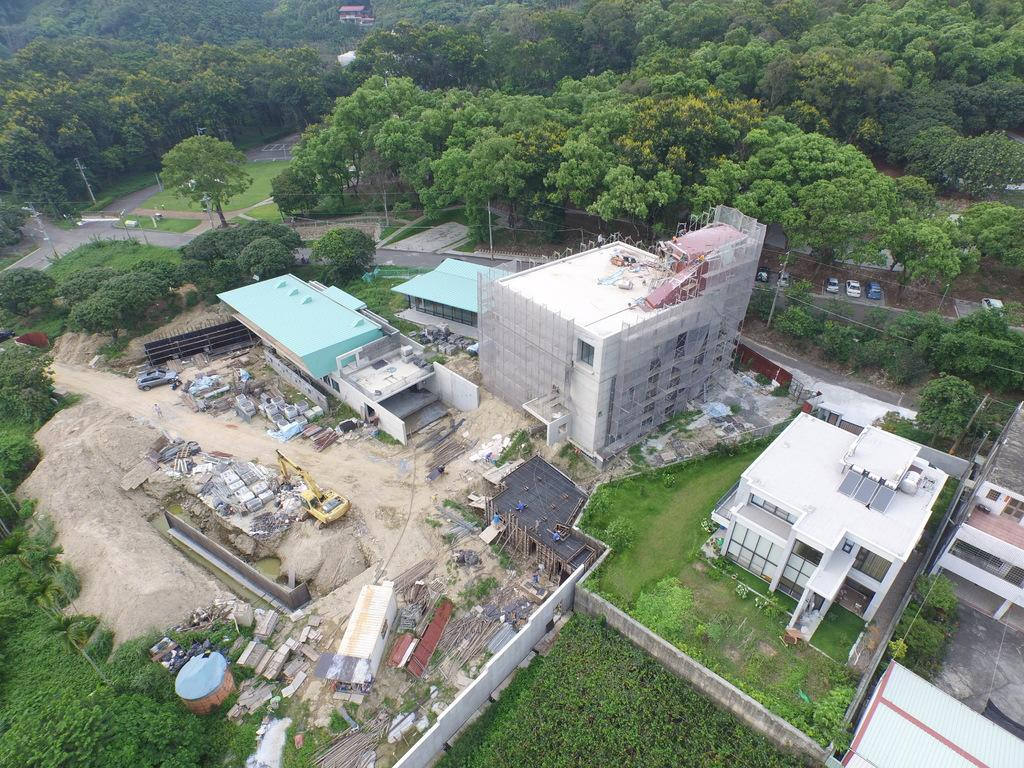What type of structures can be seen in the image? There are buildings in the image. What is the purpose of the barrier in the image? There is a fence in the image, which serves as a barrier or boundary. What type of vegetation is present in the image? There is a group of trees and plants in the image. What is the pathway used for in the image? The pathway in the image is likely used for walking or navigating through the area. How many brothers are depicted in the image? There are no people, let alone brothers, present in the image. What type of cast is visible on the trees in the image? There is no cast visible on the trees in the image; it is a group of trees without any additional features mentioned. 